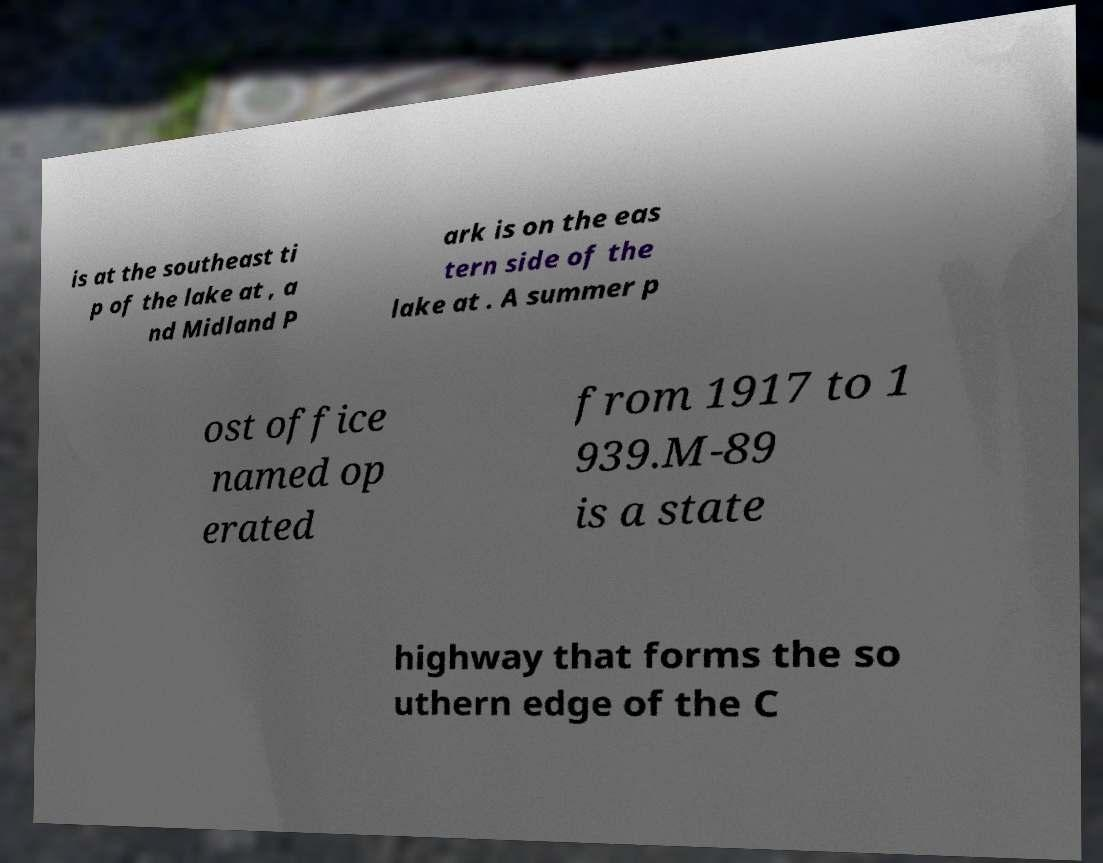Could you assist in decoding the text presented in this image and type it out clearly? is at the southeast ti p of the lake at , a nd Midland P ark is on the eas tern side of the lake at . A summer p ost office named op erated from 1917 to 1 939.M-89 is a state highway that forms the so uthern edge of the C 